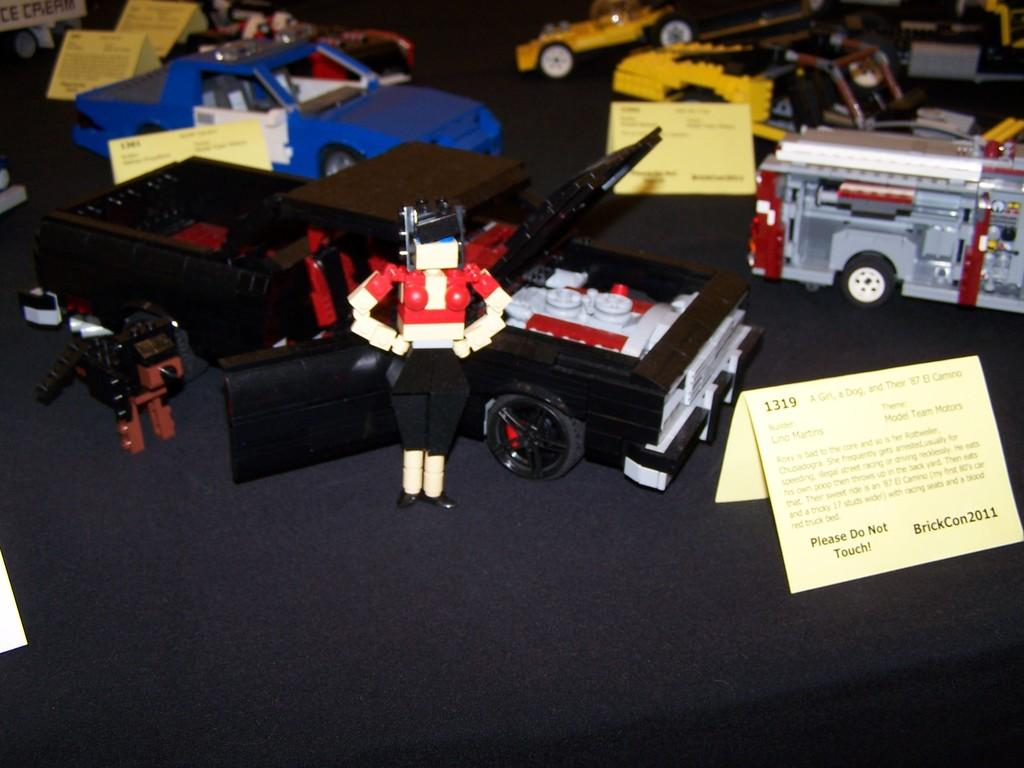<image>
Present a compact description of the photo's key features. A sign reads do not touch in front of a car model 